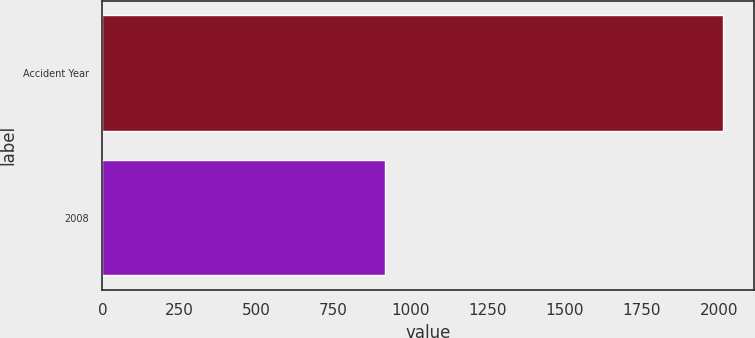Convert chart. <chart><loc_0><loc_0><loc_500><loc_500><bar_chart><fcel>Accident Year<fcel>2008<nl><fcel>2011<fcel>917<nl></chart> 